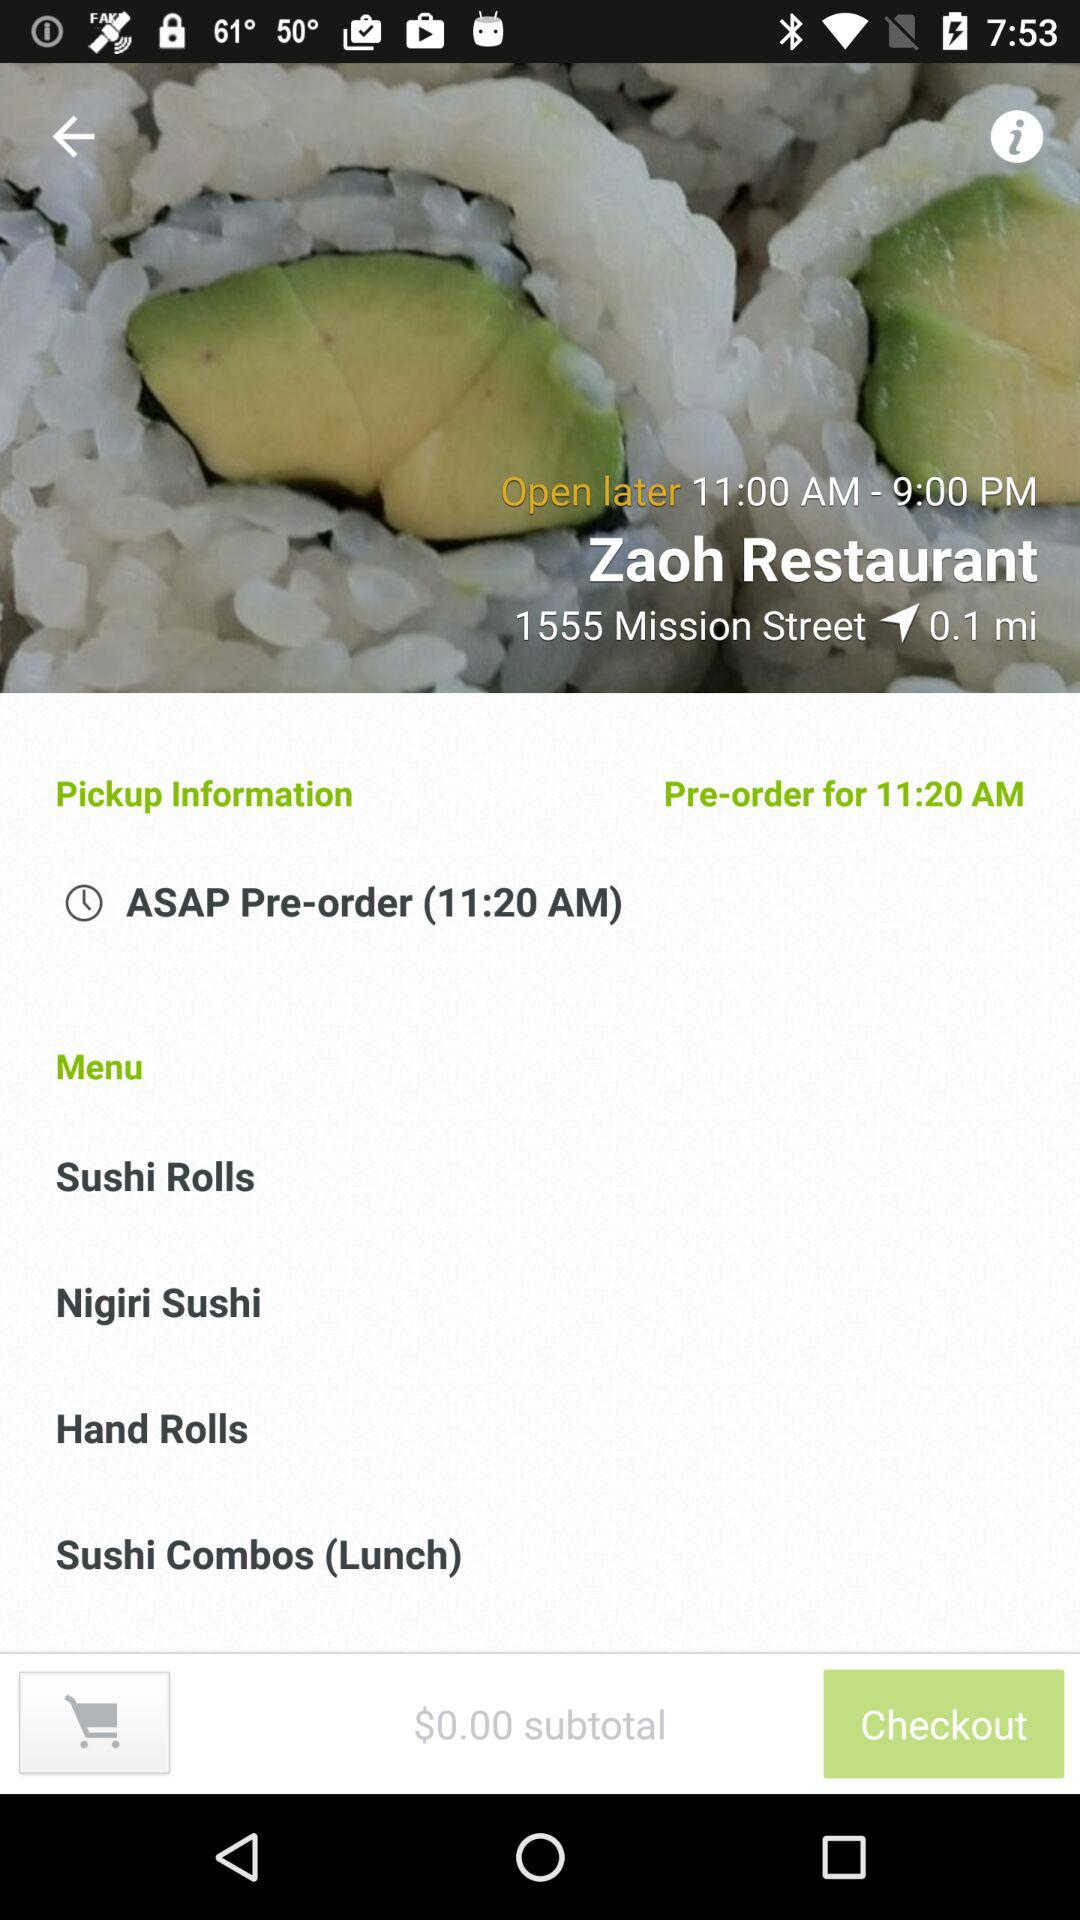How much is the subtotal?
Answer the question using a single word or phrase. $0.00 